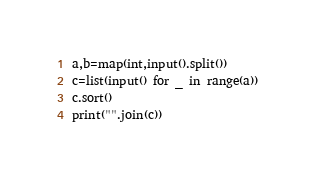Convert code to text. <code><loc_0><loc_0><loc_500><loc_500><_Python_>a,b=map(int,input().split())
c=list(input() for _ in range(a))
c.sort()
print("".join(c))
</code> 